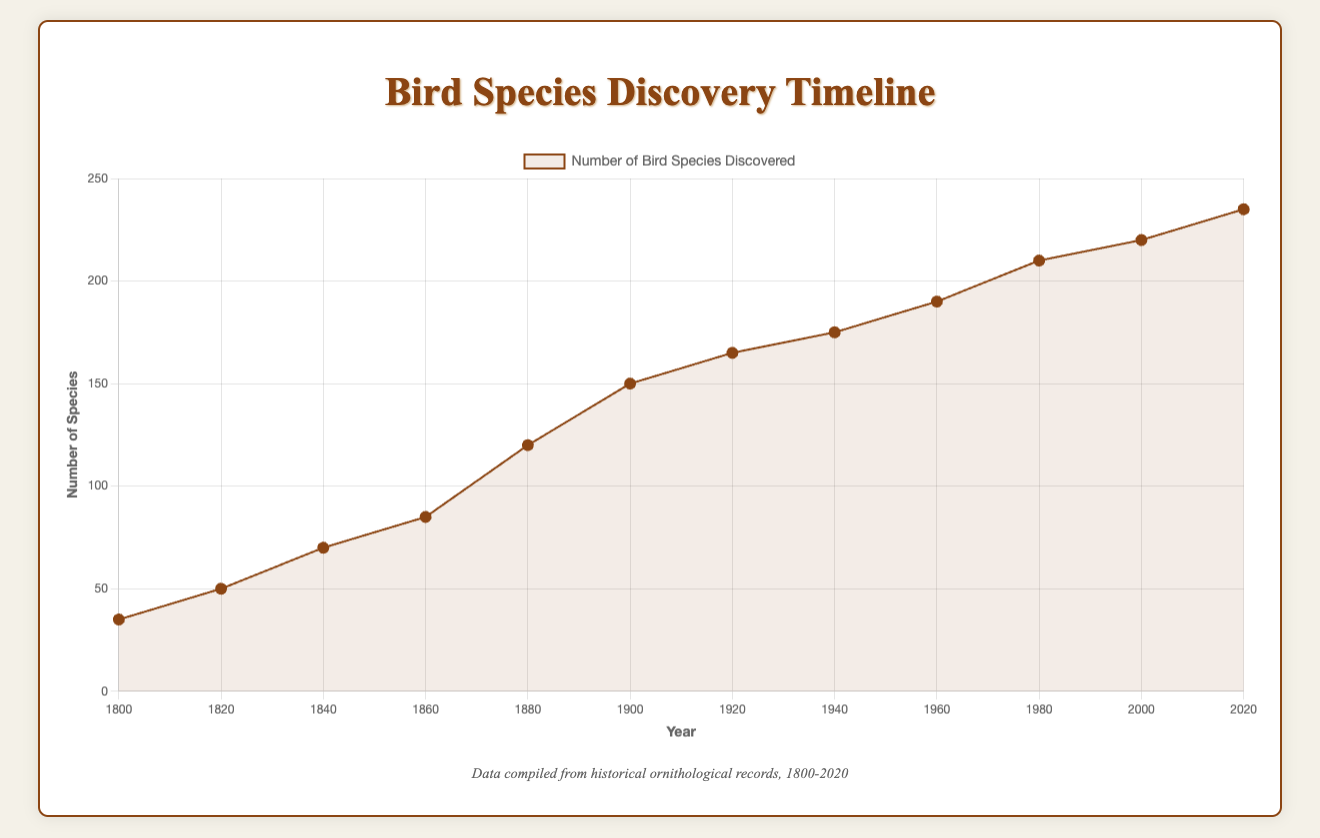What is the total number of bird species discovered by the year 1900? Sum up the number of species discovered by each year up to 1900. The values are 35 (1800), 50 (1820), 70 (1840), 85 (1860), and 120 (1880). So, the total is 35 + 50 + 70 + 85 + 120 = 360.
Answer: 360 Which period saw the highest rate of species discovery? Observe the slope of the line segments between the points. The steepest slope indicates the highest rate of discovery. The segment between 1880 and 1900 is steepest, with a change from 120 to 150 species.
Answer: 1880-1900 What is the average number of species discovered between 1920 and 1980? Sum the values for 1920 (165), 1940 (175), 1960 (190), and 1980 (210) and divide by the number of points (4). So, the average is (165 + 175 + 190 + 210) / 4 = 185.
Answer: 185 How many species were discovered by 2020 if you start from 2000? Subtract the value for 2000 from the value for 2020. The values are 220 (2000) and 235 (2020). So, the number is 235 - 220 = 15.
Answer: 15 Is there a noticeable trend of increasing or decreasing species discoveries over time? The overall trend of the line is upward, indicating an increase in the number of bird species discovered from 1800 to 2020.
Answer: Increasing Which year had the smallest increment in the number of species discovered compared to the previous year? Look at the differences between consecutive points. The smallest increment is between 1920 (165) and 1940 (175), with an increment of only 10 species.
Answer: 1940 What is the difference in the number of species discovered between 1840 and 1860? Subtract the value for 1840 from the value for 1860. The values are 70 (1840) and 85 (1860). So, the difference is 85 - 70 = 15.
Answer: 15 Are there any notable discoveries mentioned in the tooltip for the year 1980? Referring to the tooltips for the year 1980, the notable discovery is the Puerto Rican Amazon (Amazona vittata) in Puerto Rico.
Answer: Puerto Rican Amazon Which region has more notable discoveries: North America or Central Asia? North America has more notable discoveries listed (Passenger Pigeon, Ivory-billed Woodpecker) compared to Central Asia which has one mention (Sociable Lapwing).
Answer: North America 